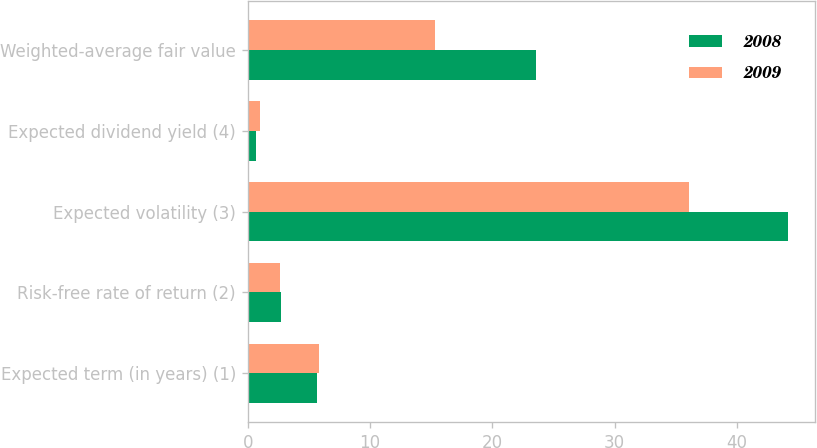Convert chart. <chart><loc_0><loc_0><loc_500><loc_500><stacked_bar_chart><ecel><fcel>Expected term (in years) (1)<fcel>Risk-free rate of return (2)<fcel>Expected volatility (3)<fcel>Expected dividend yield (4)<fcel>Weighted-average fair value<nl><fcel>2008<fcel>5.69<fcel>2.7<fcel>44.2<fcel>0.7<fcel>23.54<nl><fcel>2009<fcel>5.79<fcel>2.6<fcel>36.1<fcel>1<fcel>15.34<nl></chart> 